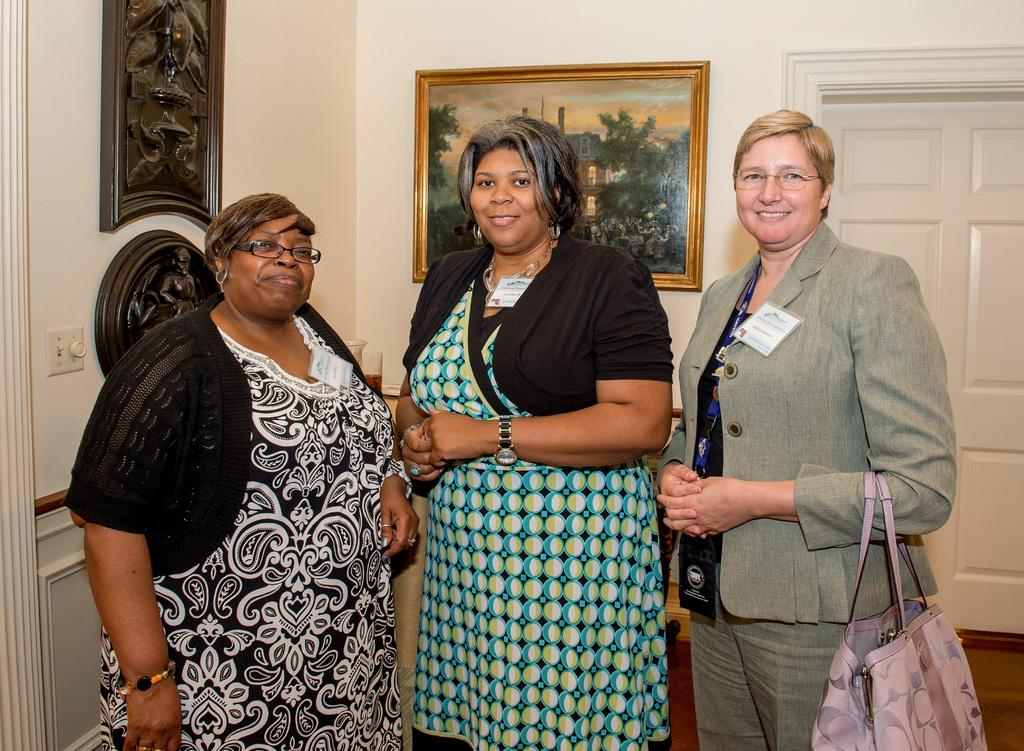How many people are present in the image? There are three people in the image. What is the facial expression of the people in the image? The people are smiling. What can be seen in the background of the image? There is a door, a wall, and photo frames in the background of the image. What type of owl can be seen perched on the door in the image? There is no owl present in the image; it only features three people and elements in the background. 